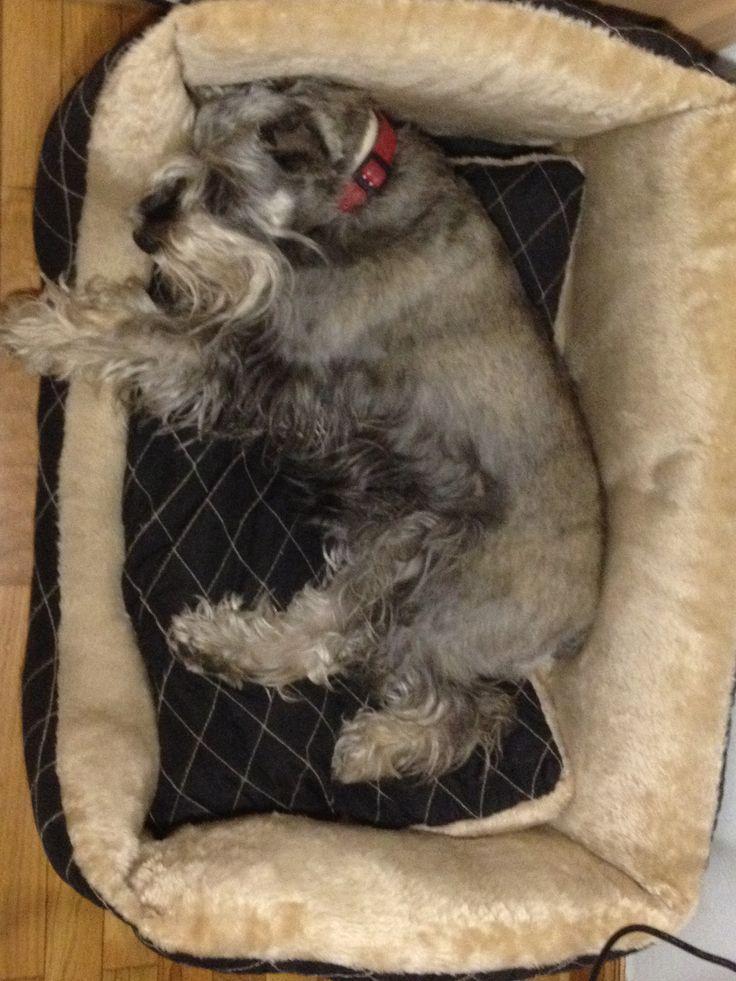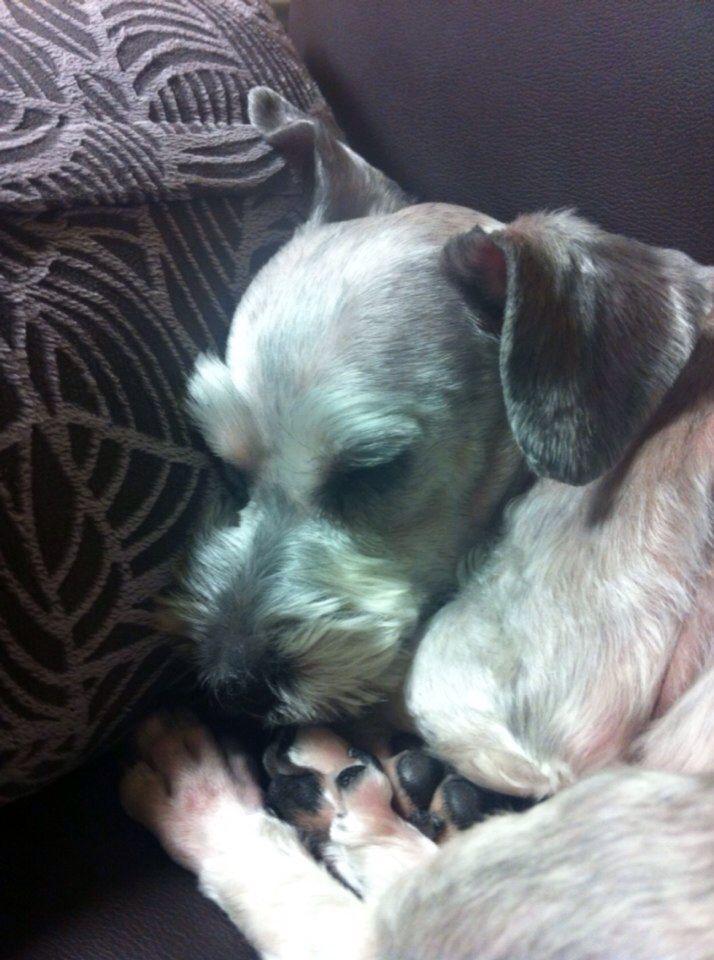The first image is the image on the left, the second image is the image on the right. Evaluate the accuracy of this statement regarding the images: "Each image shows just one dog, and one is lying down, while the other has an upright head and open eyes.". Is it true? Answer yes or no. No. The first image is the image on the left, the second image is the image on the right. For the images displayed, is the sentence "One dog is asleep, while another dog is awake." factually correct? Answer yes or no. No. 